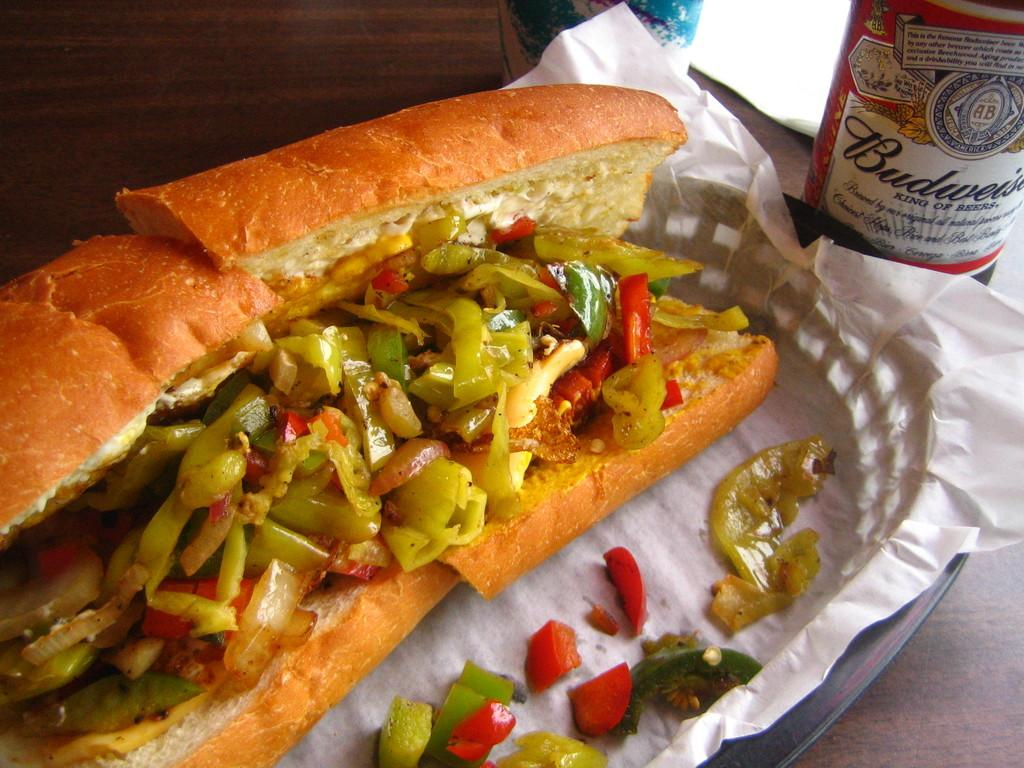What piece of furniture is present in the image? There is a table in the image. What is placed on the table? There is a tray, bottles, a paper, and a food item on the table. Can you describe the tray on the table? The tray is on the table, but its contents are not specified in the facts. What type of food item is on the table? The facts only mention that there is a food item on the table, without specifying its type. What type of chalk is being used for learning in the image? There is no chalk or learning activity present in the image. 